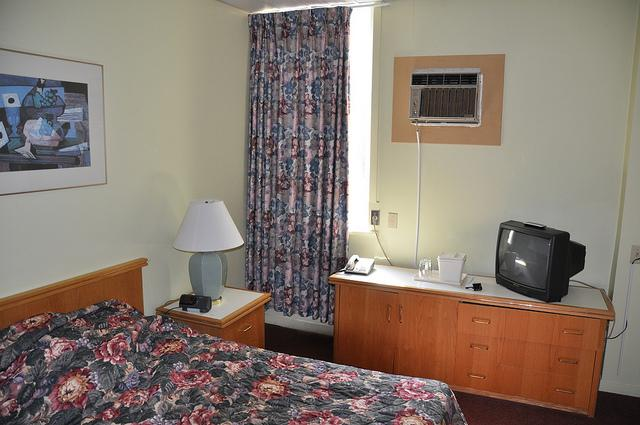What is on the dresser?

Choices:
A) roses
B) books
C) television
D) apple pie television 